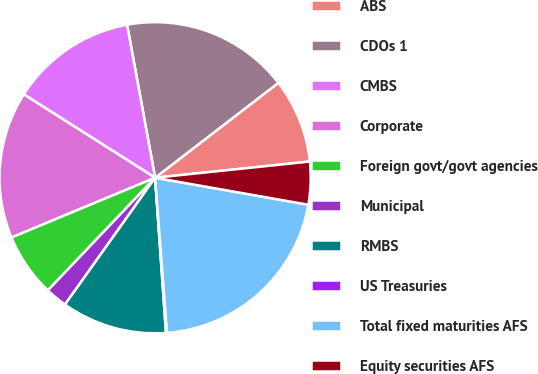Convert chart. <chart><loc_0><loc_0><loc_500><loc_500><pie_chart><fcel>ABS<fcel>CDOs 1<fcel>CMBS<fcel>Corporate<fcel>Foreign govt/govt agencies<fcel>Municipal<fcel>RMBS<fcel>US Treasuries<fcel>Total fixed maturities AFS<fcel>Equity securities AFS<nl><fcel>8.78%<fcel>17.44%<fcel>13.11%<fcel>15.28%<fcel>6.61%<fcel>2.28%<fcel>10.94%<fcel>0.11%<fcel>21.0%<fcel>4.44%<nl></chart> 